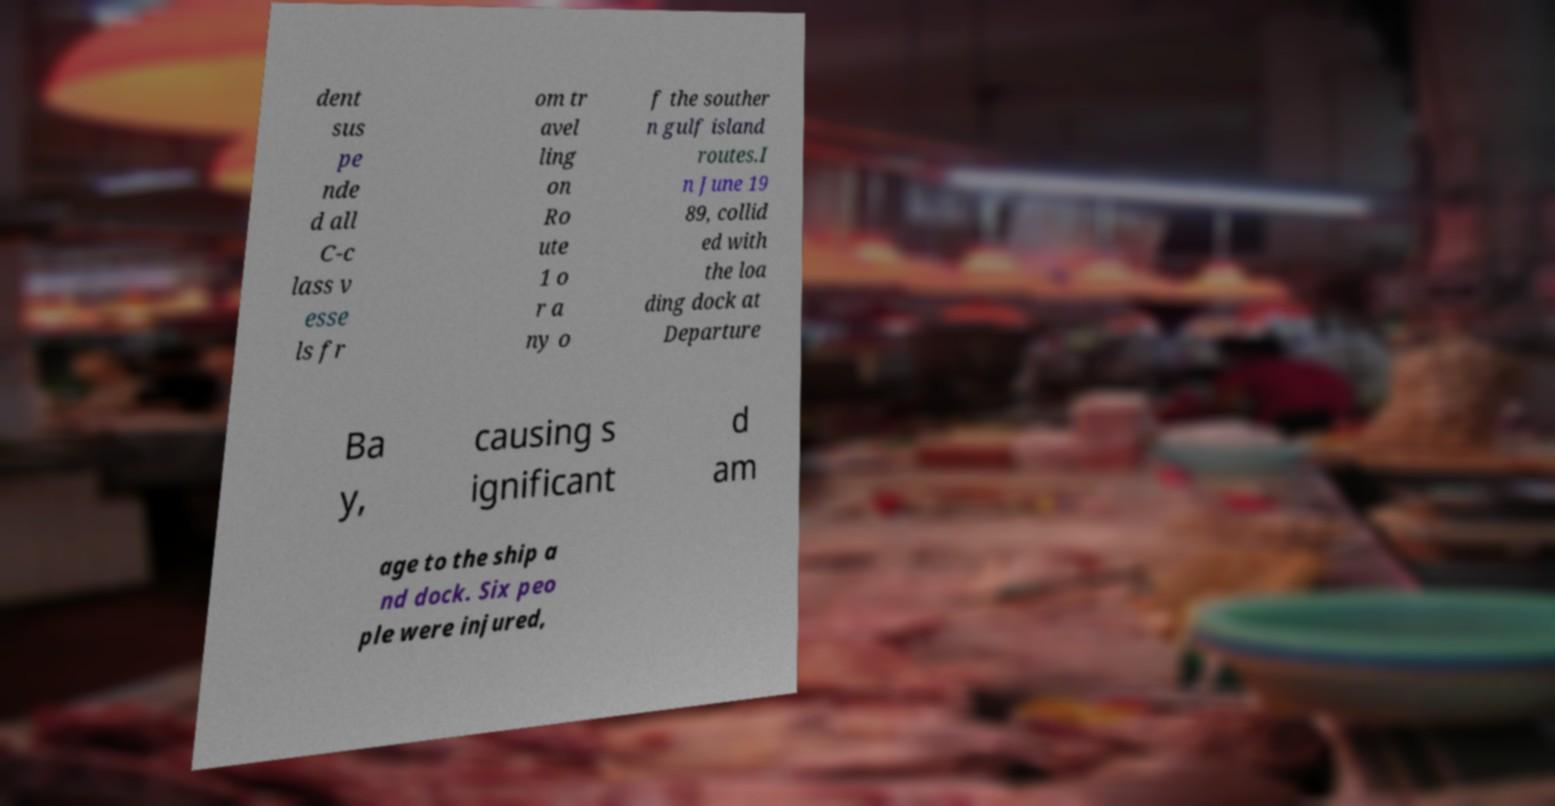I need the written content from this picture converted into text. Can you do that? dent sus pe nde d all C-c lass v esse ls fr om tr avel ling on Ro ute 1 o r a ny o f the souther n gulf island routes.I n June 19 89, collid ed with the loa ding dock at Departure Ba y, causing s ignificant d am age to the ship a nd dock. Six peo ple were injured, 